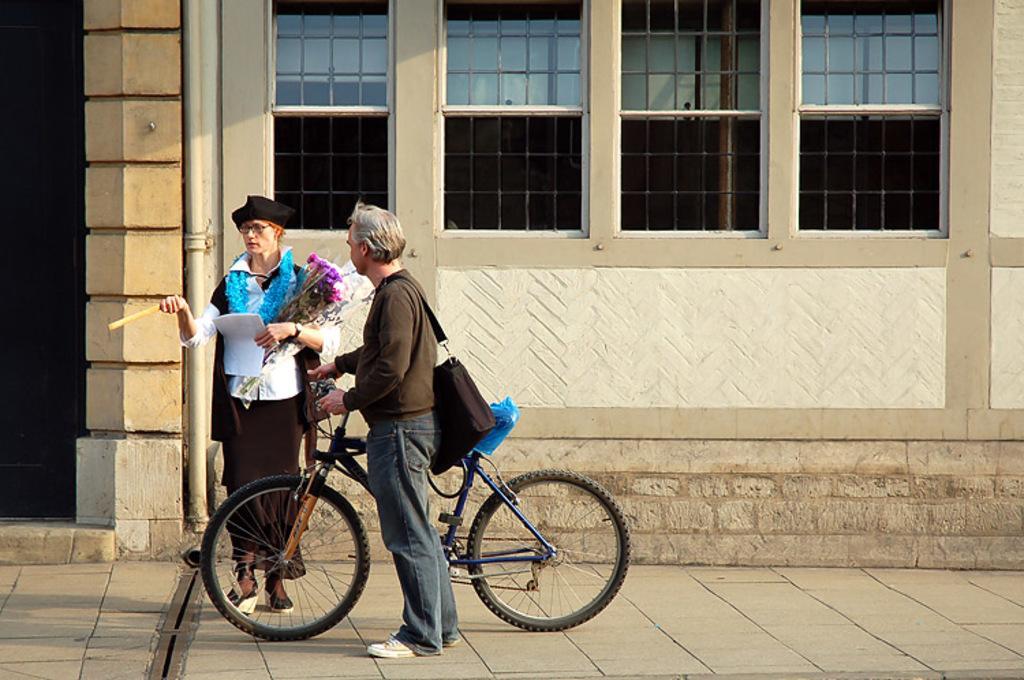Describe this image in one or two sentences. In this image we can see two persons standing on the ground. One person is carrying a bag and holding a bicycle in his hand placed on the ground. One woman is wearing a cap and spectacles is holding a paper in one hand and a stick in the other hand. In the background, we can see a building with windows. 